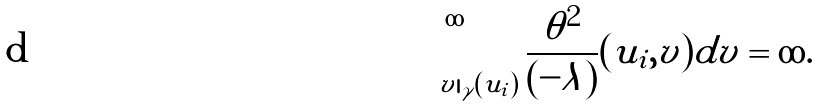<formula> <loc_0><loc_0><loc_500><loc_500>\int _ { v | _ { \gamma } ( u _ { i } ) } ^ { \infty } { \frac { \theta ^ { 2 } } { ( - \lambda ) } ( u _ { i } , v ) d v } = \infty .</formula> 